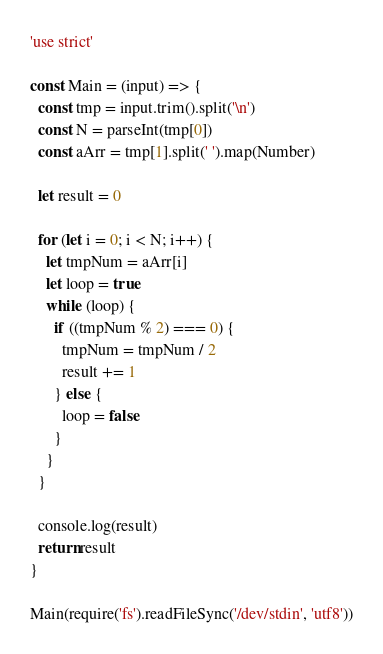Convert code to text. <code><loc_0><loc_0><loc_500><loc_500><_JavaScript_>'use strict'

const Main = (input) => {
  const tmp = input.trim().split('\n')
  const N = parseInt(tmp[0])
  const aArr = tmp[1].split(' ').map(Number)

  let result = 0

  for (let i = 0; i < N; i++) {
    let tmpNum = aArr[i]
    let loop = true
    while (loop) {
      if ((tmpNum % 2) === 0) {
        tmpNum = tmpNum / 2
        result += 1
      } else {
        loop = false
      }
    }
  }

  console.log(result)
  return result
}

Main(require('fs').readFileSync('/dev/stdin', 'utf8'))</code> 